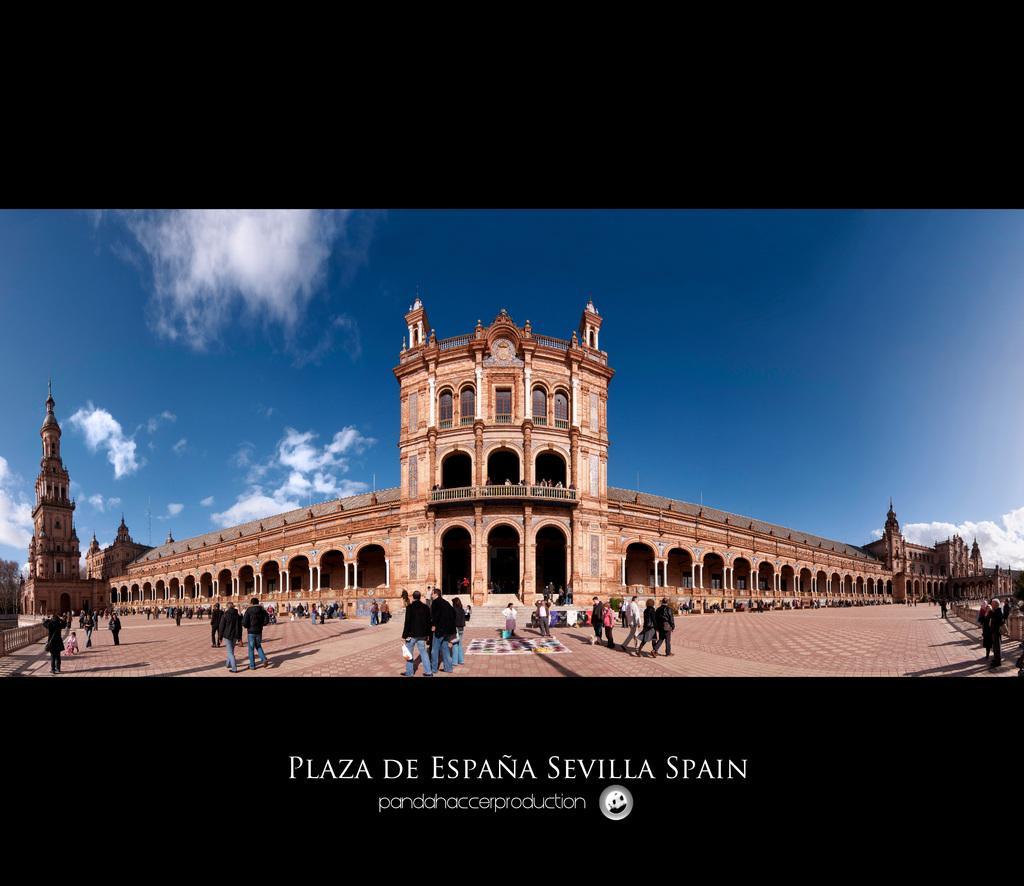In one or two sentences, can you explain what this image depicts? In this image we can see a fort. We can also see the people, path, trees, railing and also the sky with some clouds. At the bottom we can see the text and also the logo. 